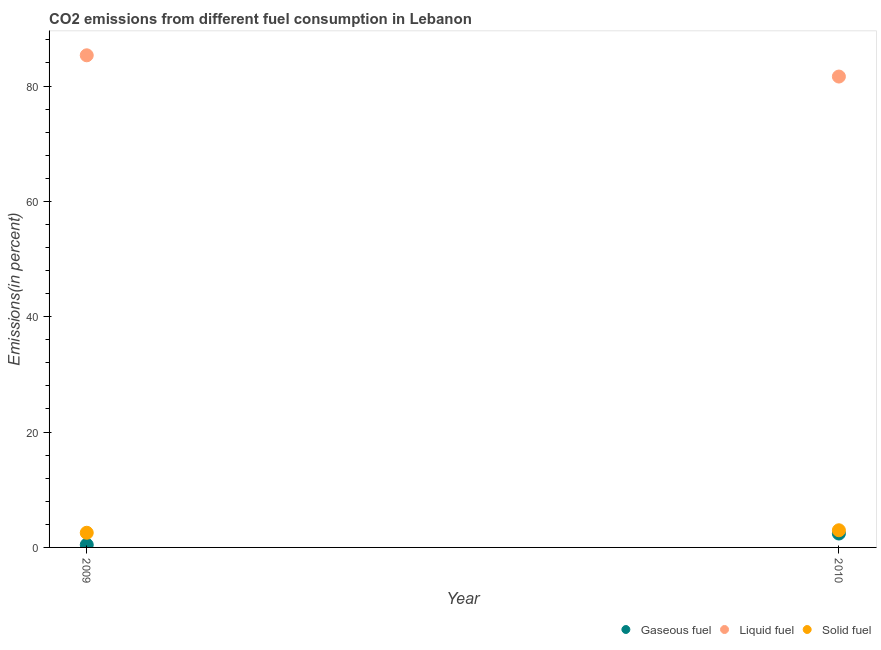How many different coloured dotlines are there?
Offer a terse response. 3. What is the percentage of gaseous fuel emission in 2010?
Provide a succinct answer. 2.41. Across all years, what is the maximum percentage of solid fuel emission?
Ensure brevity in your answer.  2.97. Across all years, what is the minimum percentage of gaseous fuel emission?
Provide a succinct answer. 0.46. In which year was the percentage of gaseous fuel emission minimum?
Make the answer very short. 2009. What is the total percentage of solid fuel emission in the graph?
Your response must be concise. 5.52. What is the difference between the percentage of liquid fuel emission in 2009 and that in 2010?
Keep it short and to the point. 3.68. What is the difference between the percentage of liquid fuel emission in 2010 and the percentage of solid fuel emission in 2009?
Your answer should be very brief. 79.1. What is the average percentage of solid fuel emission per year?
Give a very brief answer. 2.76. In the year 2009, what is the difference between the percentage of gaseous fuel emission and percentage of liquid fuel emission?
Provide a succinct answer. -84.87. In how many years, is the percentage of liquid fuel emission greater than 16 %?
Your answer should be compact. 2. What is the ratio of the percentage of liquid fuel emission in 2009 to that in 2010?
Your answer should be compact. 1.05. Is the percentage of liquid fuel emission strictly greater than the percentage of solid fuel emission over the years?
Offer a terse response. Yes. How many dotlines are there?
Your answer should be compact. 3. How many years are there in the graph?
Keep it short and to the point. 2. What is the difference between two consecutive major ticks on the Y-axis?
Your answer should be very brief. 20. Where does the legend appear in the graph?
Make the answer very short. Bottom right. How are the legend labels stacked?
Your answer should be compact. Horizontal. What is the title of the graph?
Your response must be concise. CO2 emissions from different fuel consumption in Lebanon. What is the label or title of the Y-axis?
Keep it short and to the point. Emissions(in percent). What is the Emissions(in percent) of Gaseous fuel in 2009?
Give a very brief answer. 0.46. What is the Emissions(in percent) of Liquid fuel in 2009?
Ensure brevity in your answer.  85.32. What is the Emissions(in percent) in Solid fuel in 2009?
Your response must be concise. 2.54. What is the Emissions(in percent) in Gaseous fuel in 2010?
Provide a short and direct response. 2.41. What is the Emissions(in percent) in Liquid fuel in 2010?
Your answer should be compact. 81.64. What is the Emissions(in percent) of Solid fuel in 2010?
Your response must be concise. 2.97. Across all years, what is the maximum Emissions(in percent) in Gaseous fuel?
Make the answer very short. 2.41. Across all years, what is the maximum Emissions(in percent) of Liquid fuel?
Keep it short and to the point. 85.32. Across all years, what is the maximum Emissions(in percent) of Solid fuel?
Offer a terse response. 2.97. Across all years, what is the minimum Emissions(in percent) in Gaseous fuel?
Offer a terse response. 0.46. Across all years, what is the minimum Emissions(in percent) in Liquid fuel?
Your answer should be compact. 81.64. Across all years, what is the minimum Emissions(in percent) in Solid fuel?
Your answer should be very brief. 2.54. What is the total Emissions(in percent) in Gaseous fuel in the graph?
Your answer should be very brief. 2.87. What is the total Emissions(in percent) of Liquid fuel in the graph?
Keep it short and to the point. 166.96. What is the total Emissions(in percent) in Solid fuel in the graph?
Offer a terse response. 5.52. What is the difference between the Emissions(in percent) in Gaseous fuel in 2009 and that in 2010?
Your answer should be compact. -1.95. What is the difference between the Emissions(in percent) in Liquid fuel in 2009 and that in 2010?
Your answer should be very brief. 3.68. What is the difference between the Emissions(in percent) in Solid fuel in 2009 and that in 2010?
Ensure brevity in your answer.  -0.43. What is the difference between the Emissions(in percent) of Gaseous fuel in 2009 and the Emissions(in percent) of Liquid fuel in 2010?
Provide a short and direct response. -81.18. What is the difference between the Emissions(in percent) in Gaseous fuel in 2009 and the Emissions(in percent) in Solid fuel in 2010?
Give a very brief answer. -2.52. What is the difference between the Emissions(in percent) of Liquid fuel in 2009 and the Emissions(in percent) of Solid fuel in 2010?
Provide a short and direct response. 82.35. What is the average Emissions(in percent) of Gaseous fuel per year?
Make the answer very short. 1.43. What is the average Emissions(in percent) in Liquid fuel per year?
Your answer should be very brief. 83.48. What is the average Emissions(in percent) in Solid fuel per year?
Make the answer very short. 2.76. In the year 2009, what is the difference between the Emissions(in percent) in Gaseous fuel and Emissions(in percent) in Liquid fuel?
Your response must be concise. -84.87. In the year 2009, what is the difference between the Emissions(in percent) of Gaseous fuel and Emissions(in percent) of Solid fuel?
Offer a very short reply. -2.09. In the year 2009, what is the difference between the Emissions(in percent) of Liquid fuel and Emissions(in percent) of Solid fuel?
Provide a succinct answer. 82.78. In the year 2010, what is the difference between the Emissions(in percent) of Gaseous fuel and Emissions(in percent) of Liquid fuel?
Ensure brevity in your answer.  -79.23. In the year 2010, what is the difference between the Emissions(in percent) of Gaseous fuel and Emissions(in percent) of Solid fuel?
Ensure brevity in your answer.  -0.57. In the year 2010, what is the difference between the Emissions(in percent) of Liquid fuel and Emissions(in percent) of Solid fuel?
Offer a terse response. 78.66. What is the ratio of the Emissions(in percent) of Gaseous fuel in 2009 to that in 2010?
Keep it short and to the point. 0.19. What is the ratio of the Emissions(in percent) in Liquid fuel in 2009 to that in 2010?
Your answer should be very brief. 1.05. What is the ratio of the Emissions(in percent) of Solid fuel in 2009 to that in 2010?
Your response must be concise. 0.85. What is the difference between the highest and the second highest Emissions(in percent) of Gaseous fuel?
Provide a short and direct response. 1.95. What is the difference between the highest and the second highest Emissions(in percent) in Liquid fuel?
Your response must be concise. 3.68. What is the difference between the highest and the second highest Emissions(in percent) of Solid fuel?
Ensure brevity in your answer.  0.43. What is the difference between the highest and the lowest Emissions(in percent) in Gaseous fuel?
Your response must be concise. 1.95. What is the difference between the highest and the lowest Emissions(in percent) of Liquid fuel?
Make the answer very short. 3.68. What is the difference between the highest and the lowest Emissions(in percent) of Solid fuel?
Offer a very short reply. 0.43. 